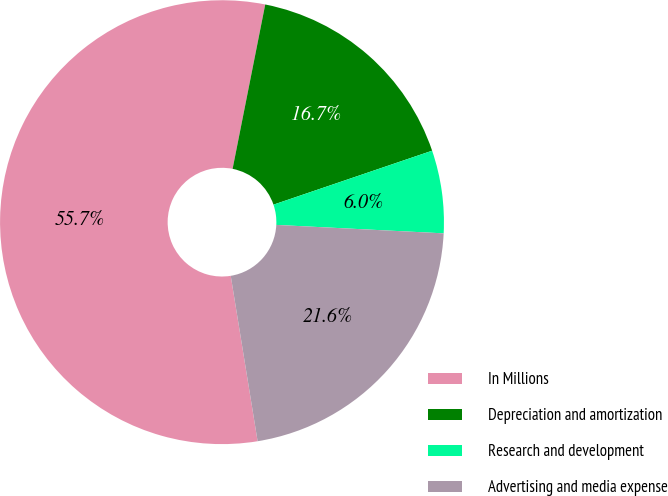Convert chart to OTSL. <chart><loc_0><loc_0><loc_500><loc_500><pie_chart><fcel>In Millions<fcel>Depreciation and amortization<fcel>Research and development<fcel>Advertising and media expense<nl><fcel>55.68%<fcel>16.66%<fcel>6.02%<fcel>21.63%<nl></chart> 